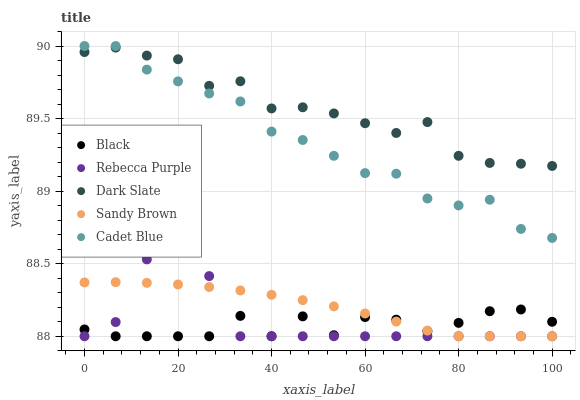Does Black have the minimum area under the curve?
Answer yes or no. Yes. Does Dark Slate have the maximum area under the curve?
Answer yes or no. Yes. Does Cadet Blue have the minimum area under the curve?
Answer yes or no. No. Does Cadet Blue have the maximum area under the curve?
Answer yes or no. No. Is Sandy Brown the smoothest?
Answer yes or no. Yes. Is Black the roughest?
Answer yes or no. Yes. Is Cadet Blue the smoothest?
Answer yes or no. No. Is Cadet Blue the roughest?
Answer yes or no. No. Does Black have the lowest value?
Answer yes or no. Yes. Does Cadet Blue have the lowest value?
Answer yes or no. No. Does Cadet Blue have the highest value?
Answer yes or no. Yes. Does Black have the highest value?
Answer yes or no. No. Is Black less than Cadet Blue?
Answer yes or no. Yes. Is Dark Slate greater than Sandy Brown?
Answer yes or no. Yes. Does Dark Slate intersect Cadet Blue?
Answer yes or no. Yes. Is Dark Slate less than Cadet Blue?
Answer yes or no. No. Is Dark Slate greater than Cadet Blue?
Answer yes or no. No. Does Black intersect Cadet Blue?
Answer yes or no. No. 